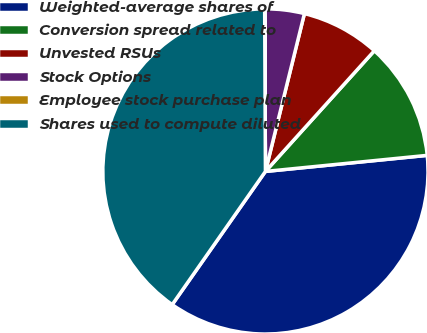Convert chart. <chart><loc_0><loc_0><loc_500><loc_500><pie_chart><fcel>Weighted-average shares of<fcel>Conversion spread related to<fcel>Unvested RSUs<fcel>Stock Options<fcel>Employee stock purchase plan<fcel>Shares used to compute diluted<nl><fcel>36.3%<fcel>11.74%<fcel>7.83%<fcel>3.92%<fcel>0.01%<fcel>40.21%<nl></chart> 